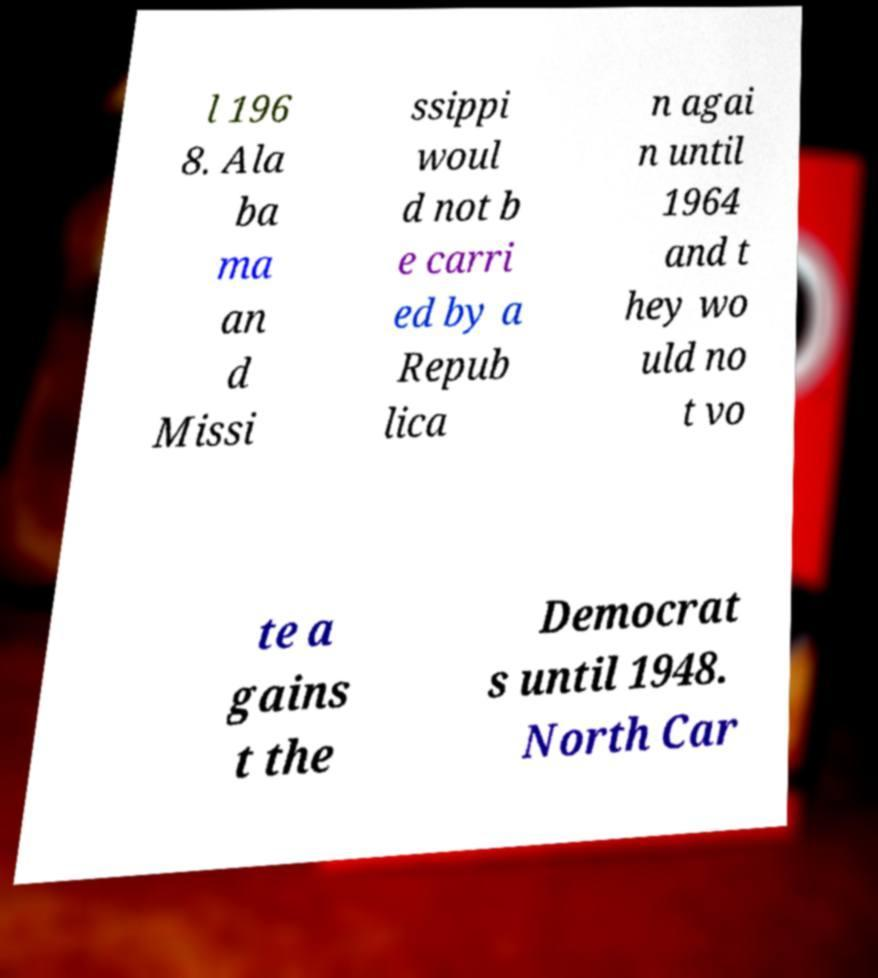Could you assist in decoding the text presented in this image and type it out clearly? l 196 8. Ala ba ma an d Missi ssippi woul d not b e carri ed by a Repub lica n agai n until 1964 and t hey wo uld no t vo te a gains t the Democrat s until 1948. North Car 